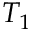Convert formula to latex. <formula><loc_0><loc_0><loc_500><loc_500>T _ { 1 }</formula> 